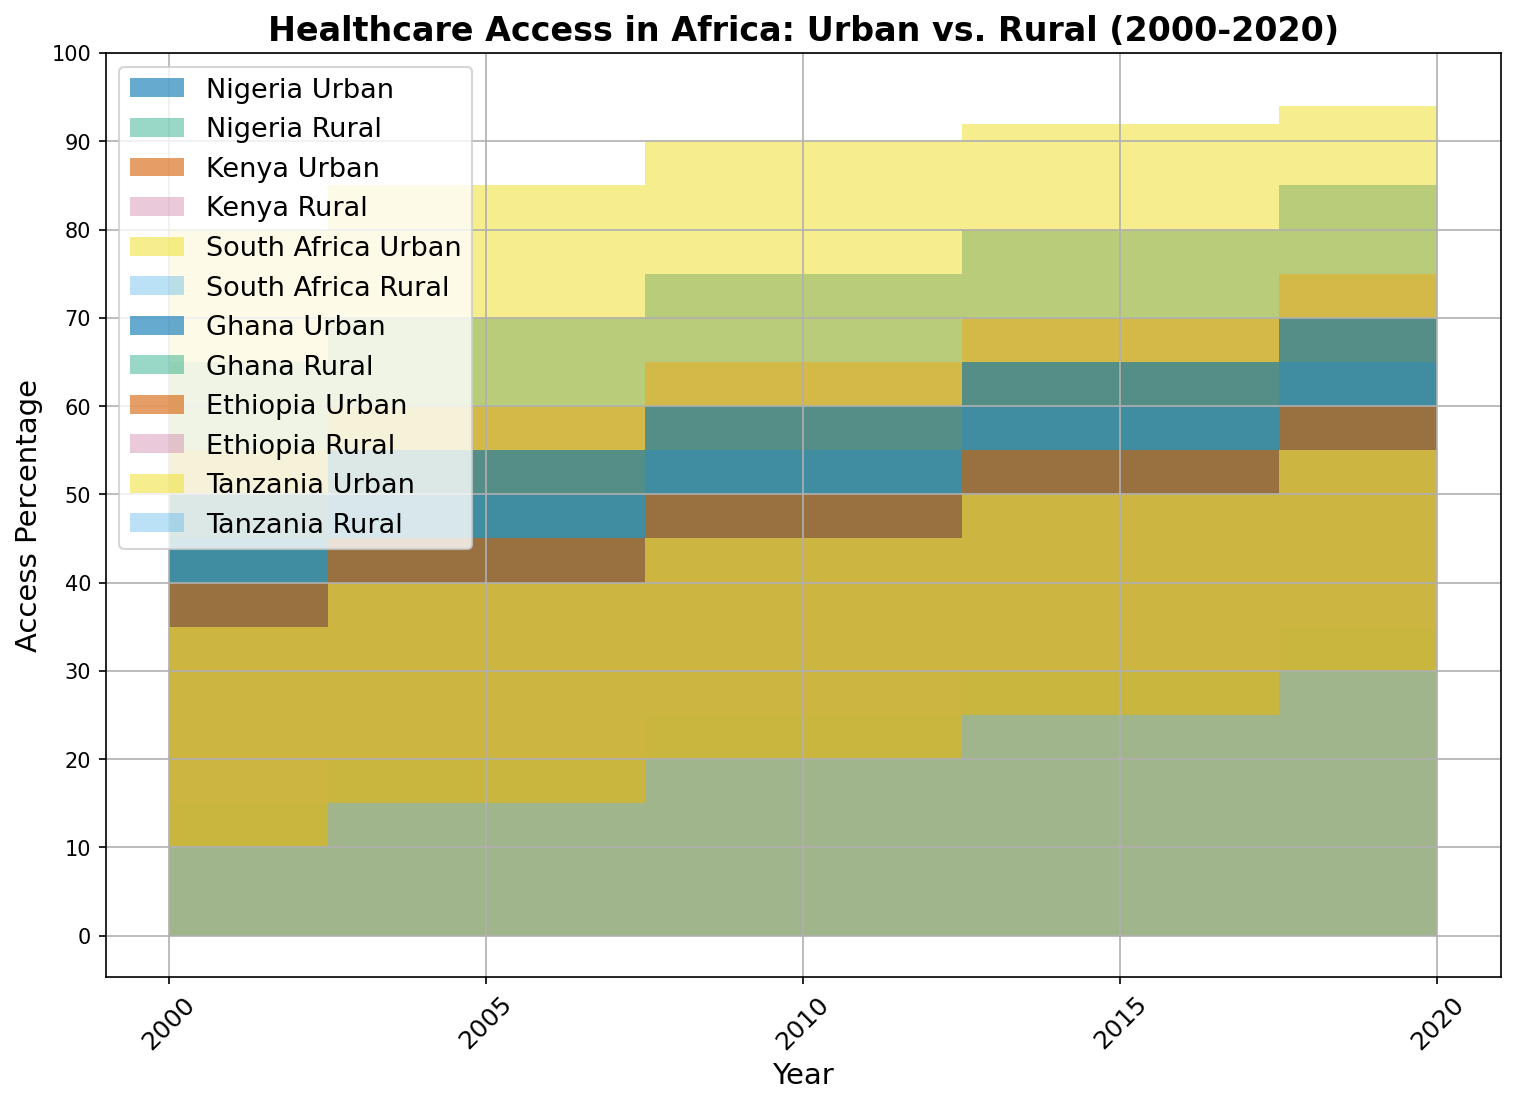What is the trend in urban healthcare access in Nigeria from 2000 to 2020? Examine the urban area under the Nigeria label over time. Access increases steadily from 65% in 2000 to 85% in 2020.
Answer: It shows consistent growth Between Kenya and Ghana, which had higher rural healthcare access in 2010? Look at the height of the rural area chart for both countries in 2010. Kenya's rural access is 30%, while Ghana's is 25%.
Answer: Kenya Which country saw the largest increase in rural healthcare access between 2000 and 2020? Compare the difference in rural access for each country between 2000 and 2020. South Africa increased from 45% to 65%, a gain of 20 percentage points.
Answer: South Africa What is the average urban healthcare access in Tanzania from 2000 to 2020? Sum the urban access percentages in Tanzania for 2000 (35%), 2005 (40%), 2010 (45%), 2015 (50%), and 2020 (55%) and divide by the number of years. (35 + 40 + 45 + 50 + 55) / 5 = 225 / 5.
Answer: 45% By how much did Ethiopia's rural healthcare access increase between 2000 and 2020? Subtract Ethiopia's rural access in 2000 (10%) from that in 2020 (30%) to find the difference. 30% - 10% = 20%.
Answer: 20% In which year did Nigeria reach 70% urban healthcare access? Identify the year on the horizontal axis where Nigeria's urban area chart reaches 70%, which is indicated in 2005.
Answer: 2005 How does the 2020 rural healthcare access in South Africa compare to that of Ethiopia? Compare the heights of the rural access between South Africa and Ethiopia in 2020. South Africa is at 65%, while Ethiopia is at 30%. South Africa's access is higher.
Answer: South Africa has higher access What is the difference in urban healthcare access between Kenya and Ghana in 2020? Compare the urban access percentages for Kenya (75%) and Ghana (70%) in 2020, then subtract Ghana's value from Kenya's. 75% - 70% = 5%.
Answer: 5% When did Ghana's rural healthcare access first reach 20%? Identify the year when Ghana's rural area chart first touches 20%, which is in 2005.
Answer: 2005 